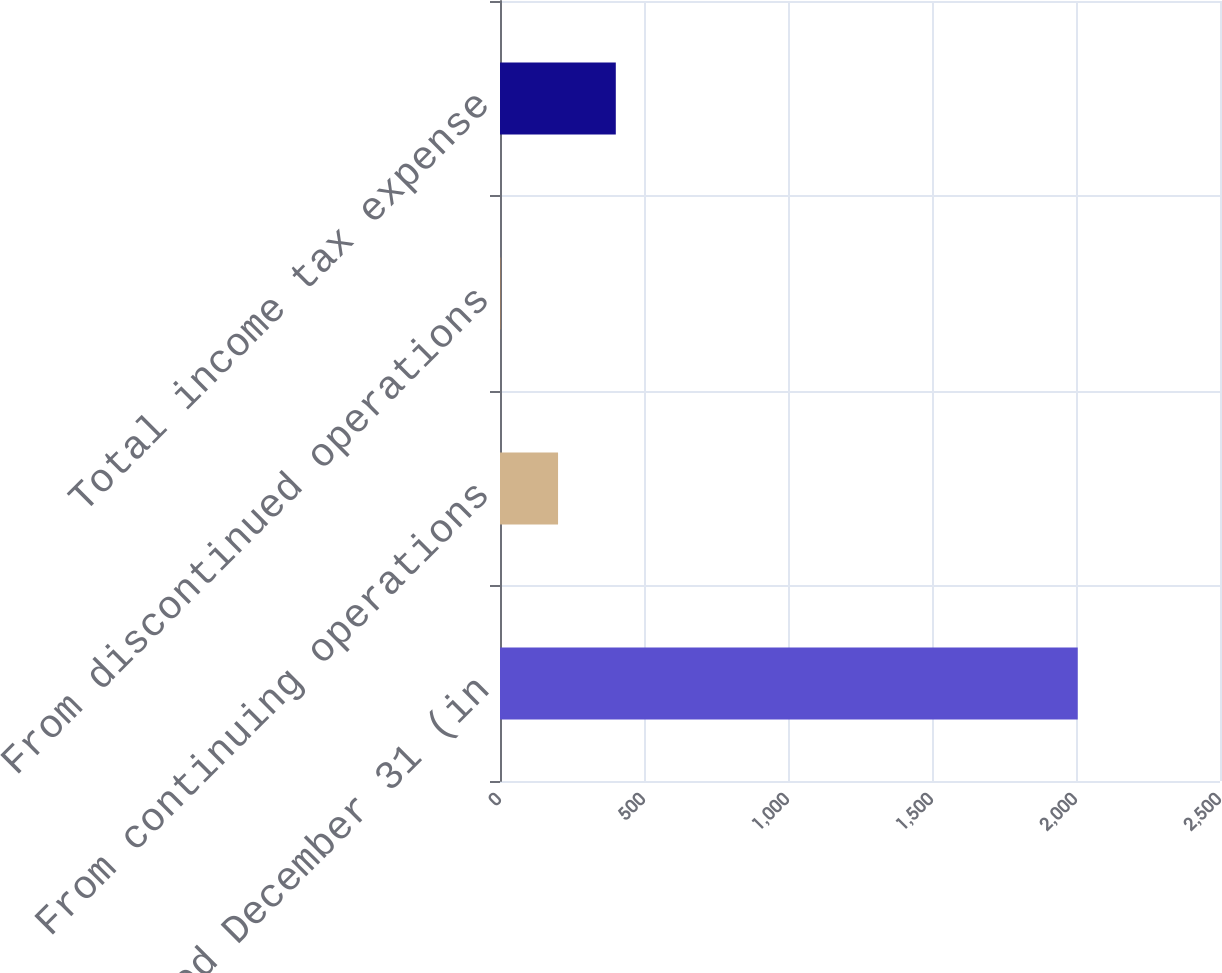<chart> <loc_0><loc_0><loc_500><loc_500><bar_chart><fcel>Years ended December 31 (in<fcel>From continuing operations<fcel>From discontinued operations<fcel>Total income tax expense<nl><fcel>2006<fcel>201.59<fcel>1.1<fcel>402.08<nl></chart> 